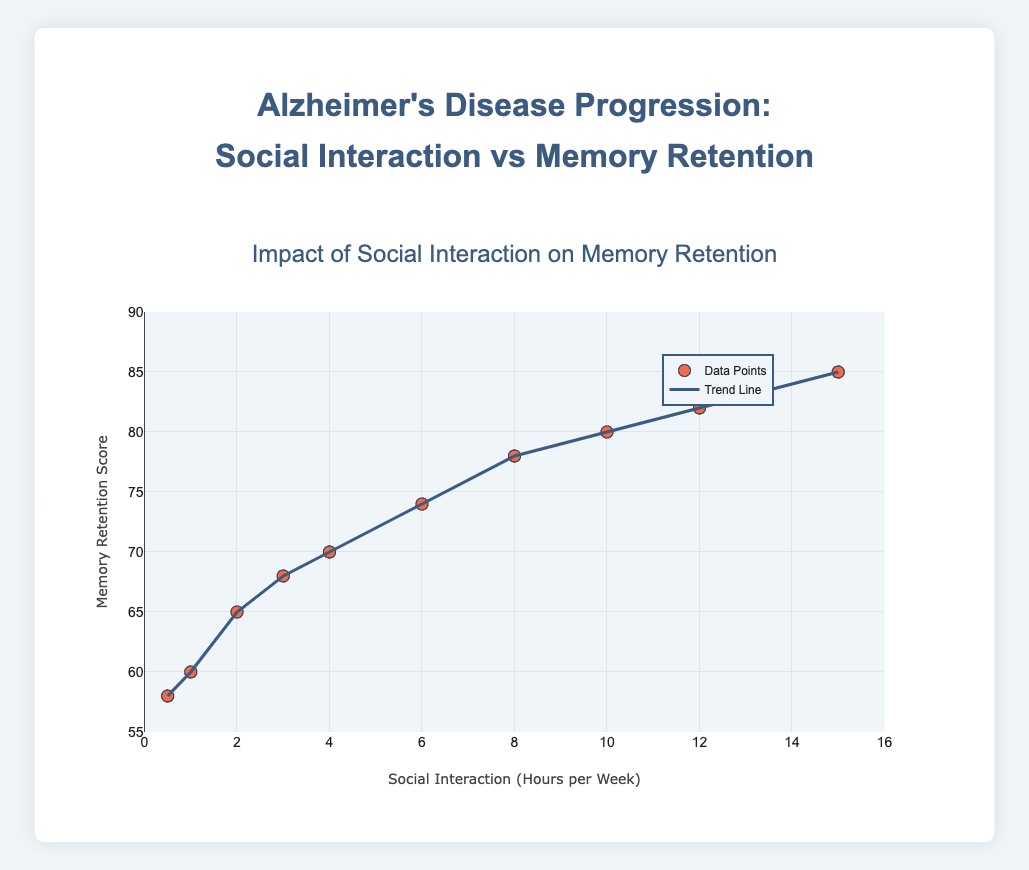What is the title of the plot? The title of the plot is located at the top and it reads "Impact of Social Interaction on Memory Retention"
Answer: Impact of Social Interaction on Memory Retention What is the range of the x-axis? The x-axis represents "Social Interaction (Hours per Week)" and ranges from 0 to 16
Answer: 0 to 16 What color are the data points? The data points in the scatter plot are shown in a red-like color, as indicated in the figure
Answer: Red-like How many data points are there in the scatter plot? Counting each point in the scatter plot reveals that there are 10 data points in total
Answer: 10 What is the Memory Retention Score at the highest level of Social Interaction Hours per Week? The plot shows a Memory Retention Score of 85 when Social Interaction Hours per Week is at 15, which is the highest level
Answer: 85 How does the Memory Retention Score change as Social Interaction Hours per Week decrease from 15 to 0.5? Analyzing the trend line from top to bottom, we see that the Memory Retention Score decreases progressively from 85 to 58 as Social Interaction Hours per Week decreases from 15 to 0.5
Answer: It decreases What is the general trend observed between Social Interaction and Memory Retention? The trend line indicates a downward trend, suggesting that Memory Retention Score decreases as Social Interaction Hours per Week decreases
Answer: Downward trend At what TimePoint is the Memory Retention Score closest to 70? Observing the data points, at TimePoint 6 the Memory Retention Score is 70, which is closest to this value
Answer: TimePoint 6 Which TimePoint shows the least amount of Social Interaction Hours per Week? According to the data, TimePoint 10 shows the lowest Social Interaction Hours per Week at 0.5
Answer: TimePoint 10 What is the average Memory Retention Score across all TimePoints? To find the average, sum all Memory Retention Scores (85 + 82 + 80 + 78 + 74 + 70 + 68 + 65 + 60 + 58) which equals 720. Then, divide by the number of TimePoints, 10. So the average is 720/10
Answer: 72 